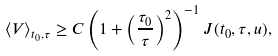<formula> <loc_0><loc_0><loc_500><loc_500>\langle V \rangle _ { t _ { 0 } , \tau } \geq C \left ( 1 + \left ( \frac { \tau _ { 0 } } { \tau } \right ) ^ { 2 } \right ) ^ { - 1 } J ( t _ { 0 } , \tau , u ) ,</formula> 